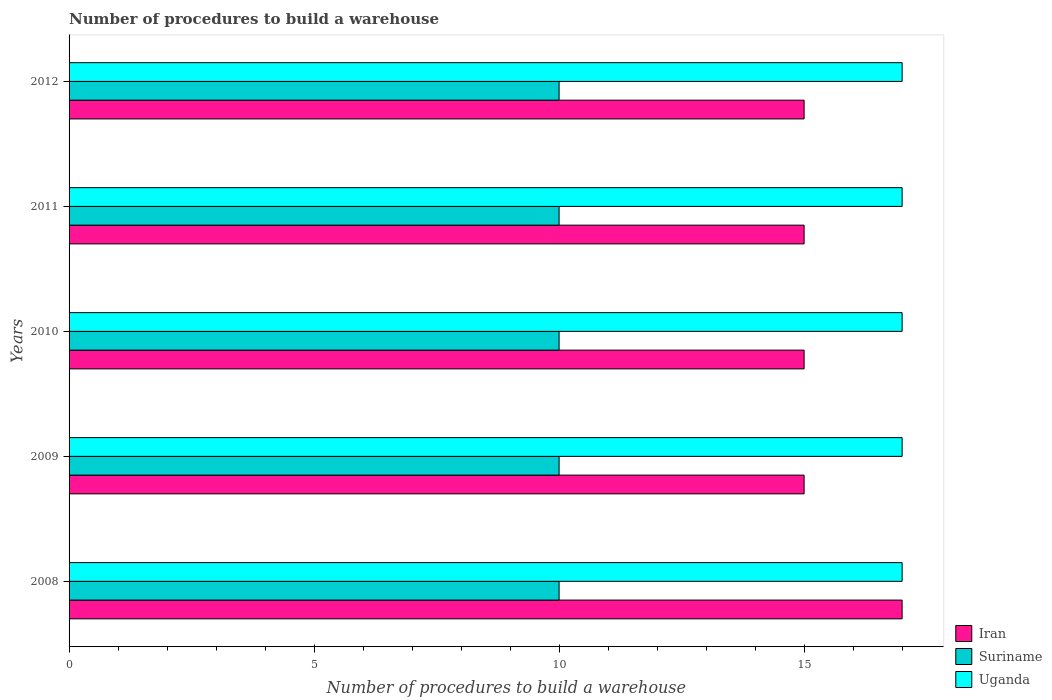What is the label of the 2nd group of bars from the top?
Your answer should be compact. 2011. What is the number of procedures to build a warehouse in in Iran in 2009?
Make the answer very short. 15. Across all years, what is the maximum number of procedures to build a warehouse in in Suriname?
Offer a terse response. 10. Across all years, what is the minimum number of procedures to build a warehouse in in Uganda?
Offer a very short reply. 17. In which year was the number of procedures to build a warehouse in in Uganda maximum?
Make the answer very short. 2008. In which year was the number of procedures to build a warehouse in in Iran minimum?
Ensure brevity in your answer.  2009. What is the total number of procedures to build a warehouse in in Suriname in the graph?
Give a very brief answer. 50. What is the difference between the number of procedures to build a warehouse in in Iran in 2010 and that in 2011?
Make the answer very short. 0. What is the difference between the number of procedures to build a warehouse in in Iran in 2010 and the number of procedures to build a warehouse in in Suriname in 2011?
Make the answer very short. 5. In the year 2010, what is the difference between the number of procedures to build a warehouse in in Suriname and number of procedures to build a warehouse in in Uganda?
Offer a terse response. -7. Is the number of procedures to build a warehouse in in Uganda in 2010 less than that in 2011?
Offer a very short reply. No. What is the difference between the highest and the lowest number of procedures to build a warehouse in in Uganda?
Offer a very short reply. 0. Is the sum of the number of procedures to build a warehouse in in Uganda in 2011 and 2012 greater than the maximum number of procedures to build a warehouse in in Suriname across all years?
Provide a succinct answer. Yes. What does the 3rd bar from the top in 2012 represents?
Provide a short and direct response. Iran. What does the 1st bar from the bottom in 2012 represents?
Your answer should be compact. Iran. What is the difference between two consecutive major ticks on the X-axis?
Your answer should be compact. 5. Does the graph contain grids?
Your answer should be compact. No. Where does the legend appear in the graph?
Give a very brief answer. Bottom right. What is the title of the graph?
Keep it short and to the point. Number of procedures to build a warehouse. What is the label or title of the X-axis?
Provide a succinct answer. Number of procedures to build a warehouse. What is the label or title of the Y-axis?
Your answer should be very brief. Years. What is the Number of procedures to build a warehouse in Iran in 2008?
Provide a succinct answer. 17. What is the Number of procedures to build a warehouse in Suriname in 2009?
Keep it short and to the point. 10. What is the Number of procedures to build a warehouse of Iran in 2010?
Give a very brief answer. 15. What is the Number of procedures to build a warehouse of Iran in 2012?
Make the answer very short. 15. What is the Number of procedures to build a warehouse in Suriname in 2012?
Ensure brevity in your answer.  10. Across all years, what is the minimum Number of procedures to build a warehouse in Suriname?
Your answer should be very brief. 10. What is the total Number of procedures to build a warehouse in Suriname in the graph?
Offer a terse response. 50. What is the total Number of procedures to build a warehouse in Uganda in the graph?
Offer a very short reply. 85. What is the difference between the Number of procedures to build a warehouse in Iran in 2008 and that in 2009?
Provide a short and direct response. 2. What is the difference between the Number of procedures to build a warehouse of Suriname in 2008 and that in 2009?
Your answer should be compact. 0. What is the difference between the Number of procedures to build a warehouse of Iran in 2008 and that in 2010?
Your answer should be very brief. 2. What is the difference between the Number of procedures to build a warehouse in Suriname in 2008 and that in 2010?
Offer a terse response. 0. What is the difference between the Number of procedures to build a warehouse in Uganda in 2008 and that in 2010?
Offer a terse response. 0. What is the difference between the Number of procedures to build a warehouse of Iran in 2008 and that in 2012?
Provide a succinct answer. 2. What is the difference between the Number of procedures to build a warehouse of Uganda in 2008 and that in 2012?
Offer a terse response. 0. What is the difference between the Number of procedures to build a warehouse of Suriname in 2009 and that in 2010?
Your answer should be compact. 0. What is the difference between the Number of procedures to build a warehouse in Uganda in 2009 and that in 2010?
Your response must be concise. 0. What is the difference between the Number of procedures to build a warehouse in Iran in 2009 and that in 2011?
Offer a terse response. 0. What is the difference between the Number of procedures to build a warehouse of Iran in 2009 and that in 2012?
Provide a short and direct response. 0. What is the difference between the Number of procedures to build a warehouse in Iran in 2010 and that in 2011?
Make the answer very short. 0. What is the difference between the Number of procedures to build a warehouse in Suriname in 2010 and that in 2011?
Keep it short and to the point. 0. What is the difference between the Number of procedures to build a warehouse of Uganda in 2010 and that in 2011?
Your response must be concise. 0. What is the difference between the Number of procedures to build a warehouse in Suriname in 2010 and that in 2012?
Provide a short and direct response. 0. What is the difference between the Number of procedures to build a warehouse in Uganda in 2010 and that in 2012?
Make the answer very short. 0. What is the difference between the Number of procedures to build a warehouse in Uganda in 2011 and that in 2012?
Give a very brief answer. 0. What is the difference between the Number of procedures to build a warehouse in Iran in 2008 and the Number of procedures to build a warehouse in Uganda in 2010?
Your answer should be compact. 0. What is the difference between the Number of procedures to build a warehouse of Iran in 2008 and the Number of procedures to build a warehouse of Suriname in 2011?
Keep it short and to the point. 7. What is the difference between the Number of procedures to build a warehouse in Iran in 2008 and the Number of procedures to build a warehouse in Uganda in 2011?
Provide a short and direct response. 0. What is the difference between the Number of procedures to build a warehouse in Suriname in 2008 and the Number of procedures to build a warehouse in Uganda in 2011?
Your answer should be very brief. -7. What is the difference between the Number of procedures to build a warehouse in Suriname in 2008 and the Number of procedures to build a warehouse in Uganda in 2012?
Keep it short and to the point. -7. What is the difference between the Number of procedures to build a warehouse of Iran in 2009 and the Number of procedures to build a warehouse of Suriname in 2010?
Your answer should be very brief. 5. What is the difference between the Number of procedures to build a warehouse in Iran in 2009 and the Number of procedures to build a warehouse in Uganda in 2010?
Keep it short and to the point. -2. What is the difference between the Number of procedures to build a warehouse of Iran in 2009 and the Number of procedures to build a warehouse of Uganda in 2011?
Keep it short and to the point. -2. What is the difference between the Number of procedures to build a warehouse of Suriname in 2009 and the Number of procedures to build a warehouse of Uganda in 2011?
Offer a very short reply. -7. What is the difference between the Number of procedures to build a warehouse of Iran in 2009 and the Number of procedures to build a warehouse of Suriname in 2012?
Your answer should be very brief. 5. What is the difference between the Number of procedures to build a warehouse of Iran in 2010 and the Number of procedures to build a warehouse of Suriname in 2011?
Your answer should be very brief. 5. What is the difference between the Number of procedures to build a warehouse of Iran in 2010 and the Number of procedures to build a warehouse of Uganda in 2011?
Your answer should be very brief. -2. What is the difference between the Number of procedures to build a warehouse of Suriname in 2010 and the Number of procedures to build a warehouse of Uganda in 2011?
Your answer should be compact. -7. What is the difference between the Number of procedures to build a warehouse of Iran in 2010 and the Number of procedures to build a warehouse of Uganda in 2012?
Your response must be concise. -2. What is the difference between the Number of procedures to build a warehouse of Suriname in 2010 and the Number of procedures to build a warehouse of Uganda in 2012?
Your response must be concise. -7. What is the difference between the Number of procedures to build a warehouse in Suriname in 2011 and the Number of procedures to build a warehouse in Uganda in 2012?
Your answer should be compact. -7. What is the average Number of procedures to build a warehouse of Iran per year?
Your answer should be compact. 15.4. What is the average Number of procedures to build a warehouse in Suriname per year?
Provide a succinct answer. 10. In the year 2008, what is the difference between the Number of procedures to build a warehouse in Iran and Number of procedures to build a warehouse in Suriname?
Your answer should be compact. 7. In the year 2008, what is the difference between the Number of procedures to build a warehouse in Iran and Number of procedures to build a warehouse in Uganda?
Your answer should be very brief. 0. In the year 2009, what is the difference between the Number of procedures to build a warehouse of Iran and Number of procedures to build a warehouse of Suriname?
Make the answer very short. 5. In the year 2010, what is the difference between the Number of procedures to build a warehouse of Iran and Number of procedures to build a warehouse of Suriname?
Give a very brief answer. 5. In the year 2011, what is the difference between the Number of procedures to build a warehouse in Iran and Number of procedures to build a warehouse in Suriname?
Your response must be concise. 5. What is the ratio of the Number of procedures to build a warehouse of Iran in 2008 to that in 2009?
Your response must be concise. 1.13. What is the ratio of the Number of procedures to build a warehouse of Uganda in 2008 to that in 2009?
Your answer should be very brief. 1. What is the ratio of the Number of procedures to build a warehouse in Iran in 2008 to that in 2010?
Offer a very short reply. 1.13. What is the ratio of the Number of procedures to build a warehouse of Uganda in 2008 to that in 2010?
Ensure brevity in your answer.  1. What is the ratio of the Number of procedures to build a warehouse in Iran in 2008 to that in 2011?
Give a very brief answer. 1.13. What is the ratio of the Number of procedures to build a warehouse in Suriname in 2008 to that in 2011?
Make the answer very short. 1. What is the ratio of the Number of procedures to build a warehouse of Uganda in 2008 to that in 2011?
Give a very brief answer. 1. What is the ratio of the Number of procedures to build a warehouse of Iran in 2008 to that in 2012?
Provide a short and direct response. 1.13. What is the ratio of the Number of procedures to build a warehouse in Uganda in 2009 to that in 2010?
Offer a very short reply. 1. What is the ratio of the Number of procedures to build a warehouse in Uganda in 2009 to that in 2011?
Your response must be concise. 1. What is the ratio of the Number of procedures to build a warehouse in Iran in 2009 to that in 2012?
Keep it short and to the point. 1. What is the ratio of the Number of procedures to build a warehouse of Suriname in 2010 to that in 2011?
Provide a short and direct response. 1. What is the ratio of the Number of procedures to build a warehouse of Iran in 2010 to that in 2012?
Keep it short and to the point. 1. What is the ratio of the Number of procedures to build a warehouse of Suriname in 2010 to that in 2012?
Your answer should be compact. 1. What is the ratio of the Number of procedures to build a warehouse in Iran in 2011 to that in 2012?
Keep it short and to the point. 1. What is the ratio of the Number of procedures to build a warehouse in Uganda in 2011 to that in 2012?
Offer a terse response. 1. What is the difference between the highest and the second highest Number of procedures to build a warehouse in Suriname?
Give a very brief answer. 0. What is the difference between the highest and the second highest Number of procedures to build a warehouse of Uganda?
Make the answer very short. 0. What is the difference between the highest and the lowest Number of procedures to build a warehouse in Iran?
Your answer should be compact. 2. What is the difference between the highest and the lowest Number of procedures to build a warehouse of Uganda?
Offer a terse response. 0. 